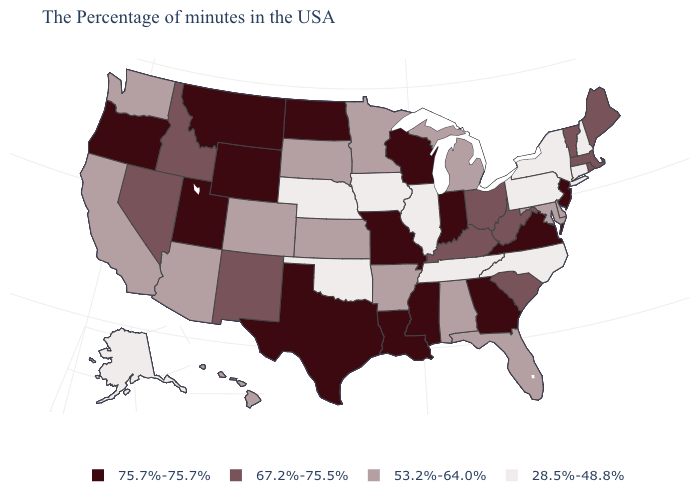Is the legend a continuous bar?
Write a very short answer. No. What is the highest value in the USA?
Be succinct. 75.7%-75.7%. What is the value of Alabama?
Write a very short answer. 53.2%-64.0%. Which states have the lowest value in the USA?
Be succinct. New Hampshire, Connecticut, New York, Pennsylvania, North Carolina, Tennessee, Illinois, Iowa, Nebraska, Oklahoma, Alaska. Does the first symbol in the legend represent the smallest category?
Write a very short answer. No. What is the value of Wyoming?
Quick response, please. 75.7%-75.7%. What is the value of Minnesota?
Short answer required. 53.2%-64.0%. Which states have the lowest value in the USA?
Answer briefly. New Hampshire, Connecticut, New York, Pennsylvania, North Carolina, Tennessee, Illinois, Iowa, Nebraska, Oklahoma, Alaska. Name the states that have a value in the range 75.7%-75.7%?
Short answer required. New Jersey, Virginia, Georgia, Indiana, Wisconsin, Mississippi, Louisiana, Missouri, Texas, North Dakota, Wyoming, Utah, Montana, Oregon. How many symbols are there in the legend?
Write a very short answer. 4. What is the value of Pennsylvania?
Write a very short answer. 28.5%-48.8%. Does Wyoming have the highest value in the USA?
Concise answer only. Yes. Does Mississippi have the highest value in the USA?
Concise answer only. Yes. Does the map have missing data?
Quick response, please. No. Name the states that have a value in the range 67.2%-75.5%?
Keep it brief. Maine, Massachusetts, Rhode Island, Vermont, South Carolina, West Virginia, Ohio, Kentucky, New Mexico, Idaho, Nevada. 